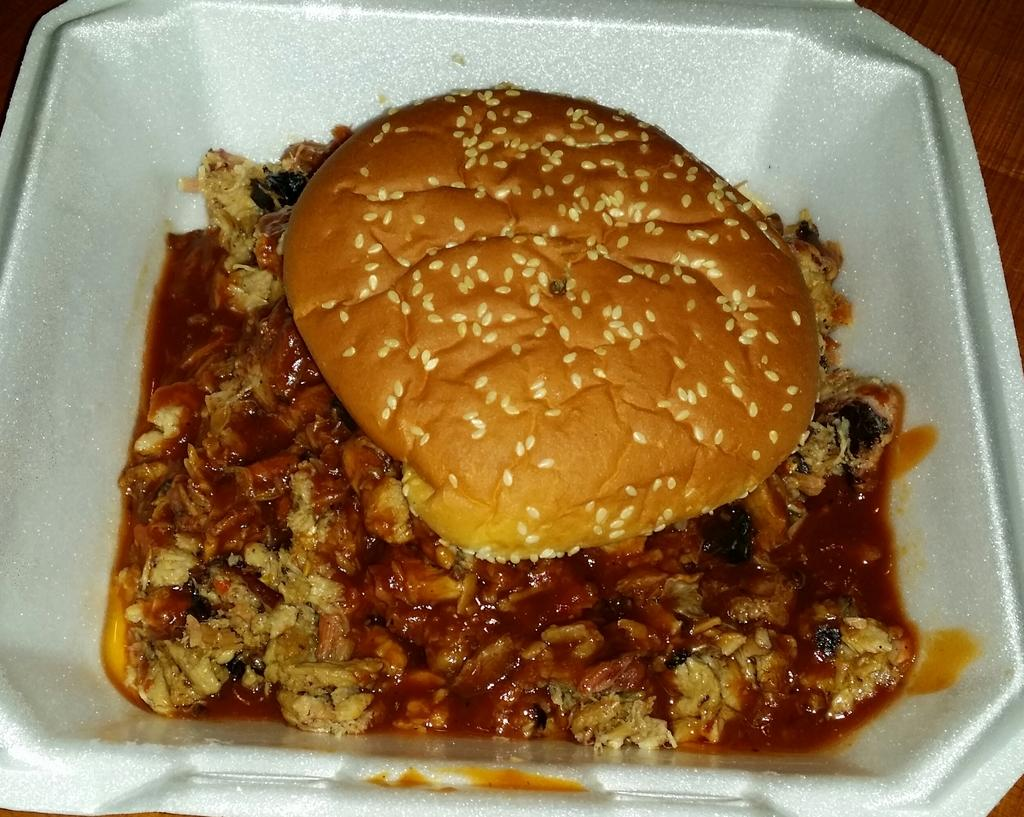What color is the bowl that is visible in the image? There is a white bowl in the image. What is inside the bowl in the image? There is food in the white bowl. What type of sign can be seen in the image? There is no sign present in the image. What type of wave can be seen in the image? There is no wave present in the image. 